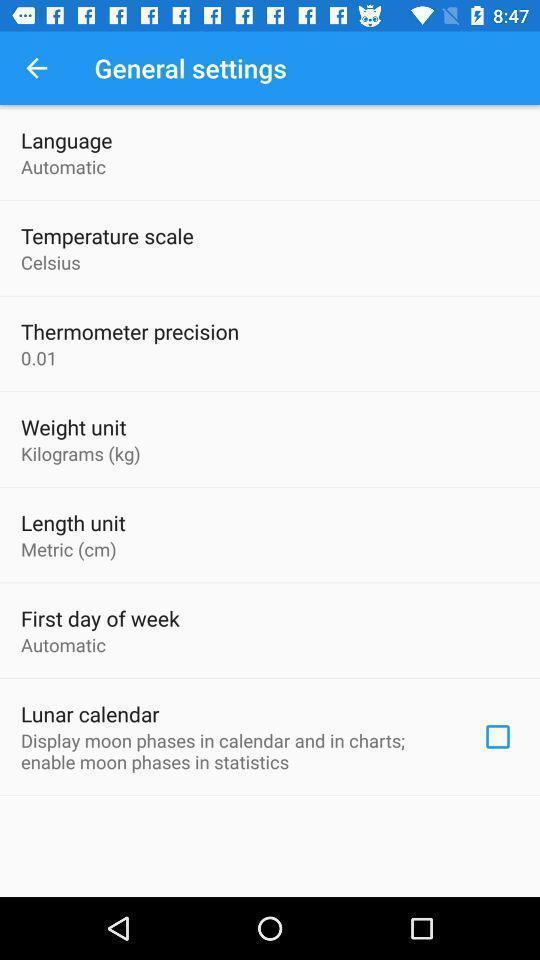Describe the key features of this screenshot. Page showing different general setting options on an app. 